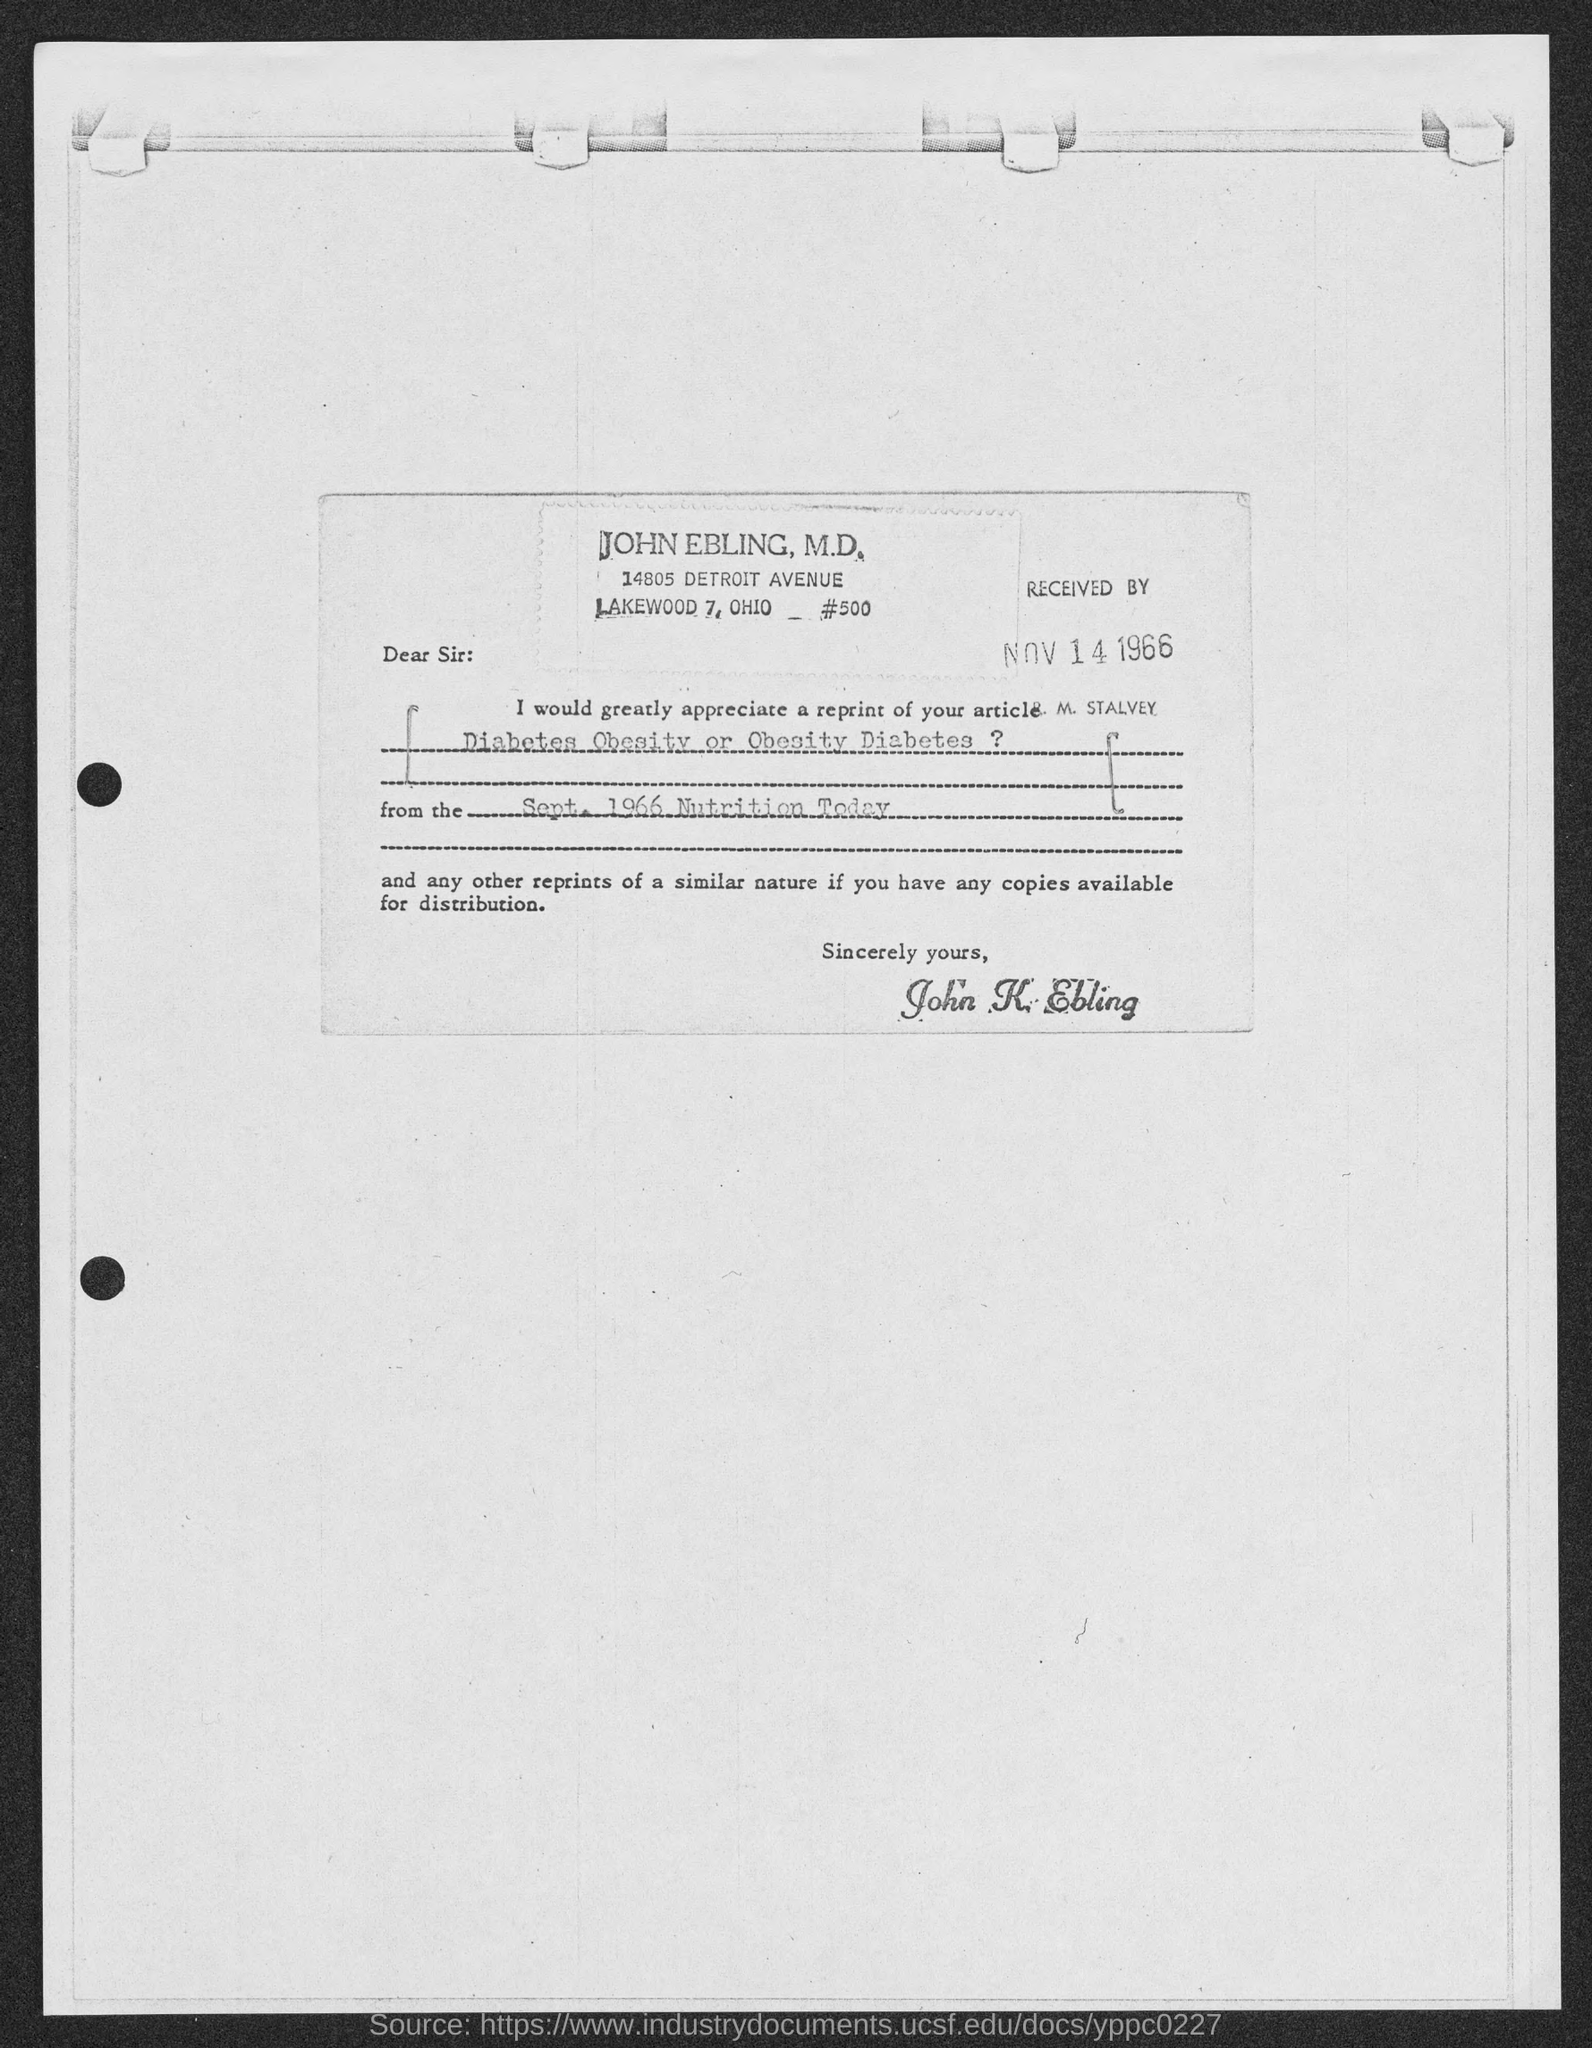What is the issue date of article on diabetes obesity or obesity diabetes ?
Provide a short and direct response. SEPT. 1966. What is the name of magazine?
Give a very brief answer. Nutrition Today. 